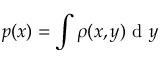<formula> <loc_0><loc_0><loc_500><loc_500>p ( x ) = \int \rho ( x , y ) d y</formula> 